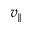<formula> <loc_0><loc_0><loc_500><loc_500>v _ { \| }</formula> 